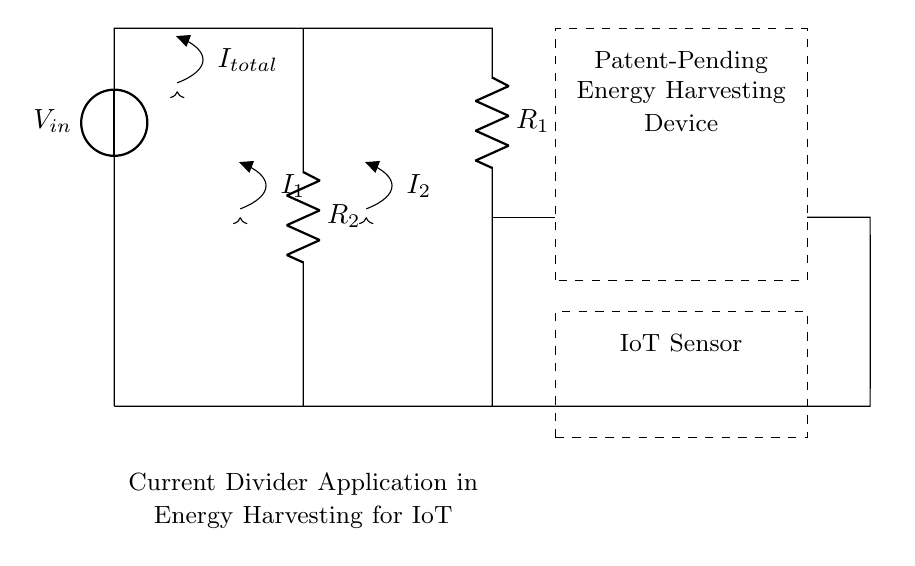What is the input voltage of the circuit? The input voltage is indicated as V in the circuit diagram. The label on the voltage source provides this information directly.
Answer: V What type of circuit is depicted? The circuit is a current divider, as it is designed to divide the total current into two parts flowing through resistors. This is determined by the arrangement of the resistors in parallel.
Answer: Current divider What are the resistor values labeled in the circuit? The resistors are labeled as R_1 and R_2. The actual numerical values for these resistors are not given in the diagram but are referenced generally.
Answer: R_1 and R_2 What is the total current flowing into the circuit? The total current is denoted as I_total, which is shown as entering the circuit at the input voltage source. This label indicates the flow of current into the circuit.
Answer: I_total How is the current distributed in the circuit? The current is divided into two branches: I_1 through R_1 and I_2 through R_2. This division is a direct consequence of the parallel configuration of the resistors, which influences the amount of current flowing through each branch based on their resistances.
Answer: I_1 and I_2 What component represents the IoT sensor in the diagram? The IoT sensor is represented in the circuit by a dashed rectangle labeled "IoT Sensor". This rectangle visually distinguishes it from other components and indicates its presence in the application context.
Answer: IoT Sensor What function does the dashed rectangle serve in the circuit? The dashed rectangles indicate different functional blocks or applications in the circuit. The upper rectangle represents the patent-pending energy harvesting device, while the lower corresponds to the IoT sensor, indicating their relationship within the overall system.
Answer: Functional grouping 